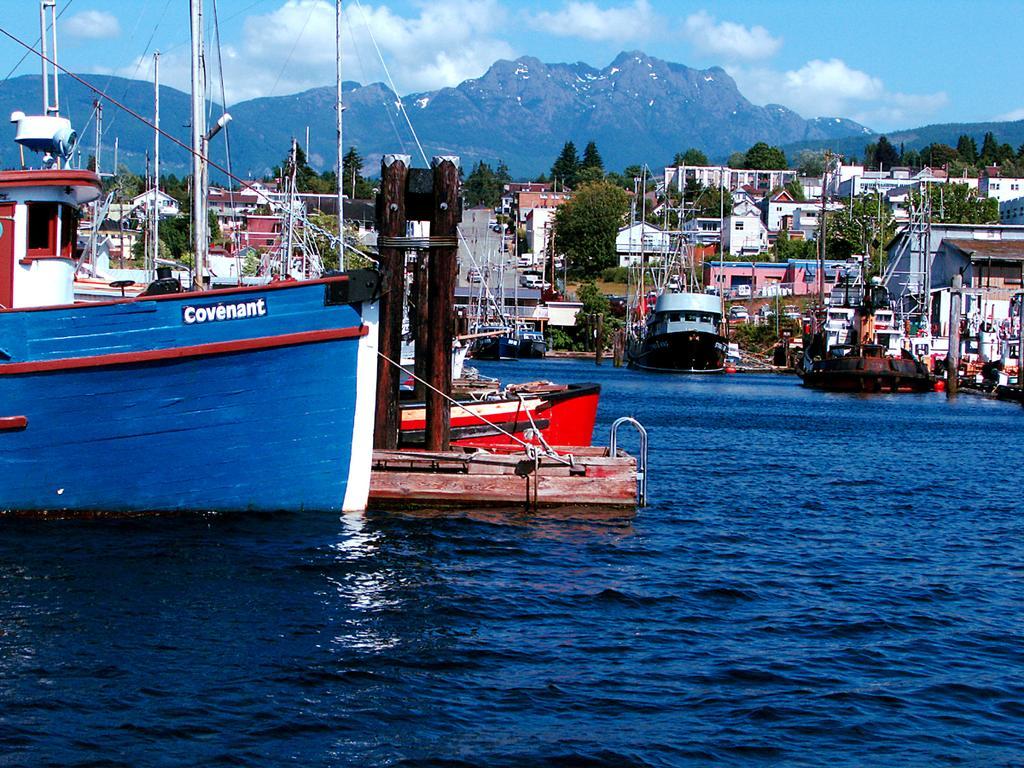In one or two sentences, can you explain what this image depicts? There are ships on the water. Here we can see trees, poles, vehicles, and buildings. In the background we can see mountain and sky with clouds. 